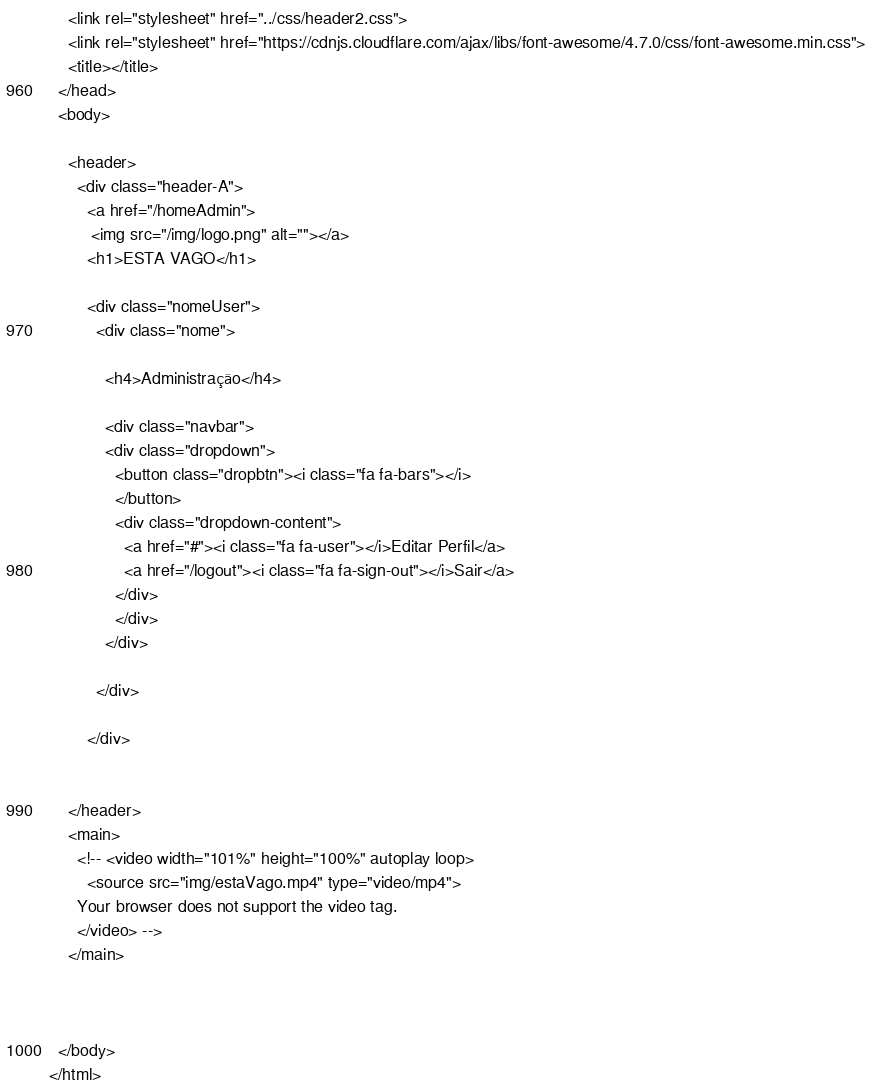Convert code to text. <code><loc_0><loc_0><loc_500><loc_500><_PHP_>    <link rel="stylesheet" href="../css/header2.css">
    <link rel="stylesheet" href="https://cdnjs.cloudflare.com/ajax/libs/font-awesome/4.7.0/css/font-awesome.min.css">
    <title></title>
  </head>
  <body>

    <header>
      <div class="header-A">
        <a href="/homeAdmin">
         <img src="/img/logo.png" alt=""></a>
        <h1>ESTA VAGO</h1>

        <div class="nomeUser">
          <div class="nome">

            <h4>Administração</h4>

            <div class="navbar">
            <div class="dropdown">
              <button class="dropbtn"><i class="fa fa-bars"></i>
              </button>
              <div class="dropdown-content">
                <a href="#"><i class="fa fa-user"></i>Editar Perfil</a>
                <a href="/logout"><i class="fa fa-sign-out"></i>Sair</a>
              </div>
              </div>
            </div>

          </div>

        </div>


    </header>
    <main>
      <!-- <video width="101%" height="100%" autoplay loop>
        <source src="img/estaVago.mp4" type="video/mp4">
      Your browser does not support the video tag.
      </video> -->
    </main>



  </body>
</html>
</code> 